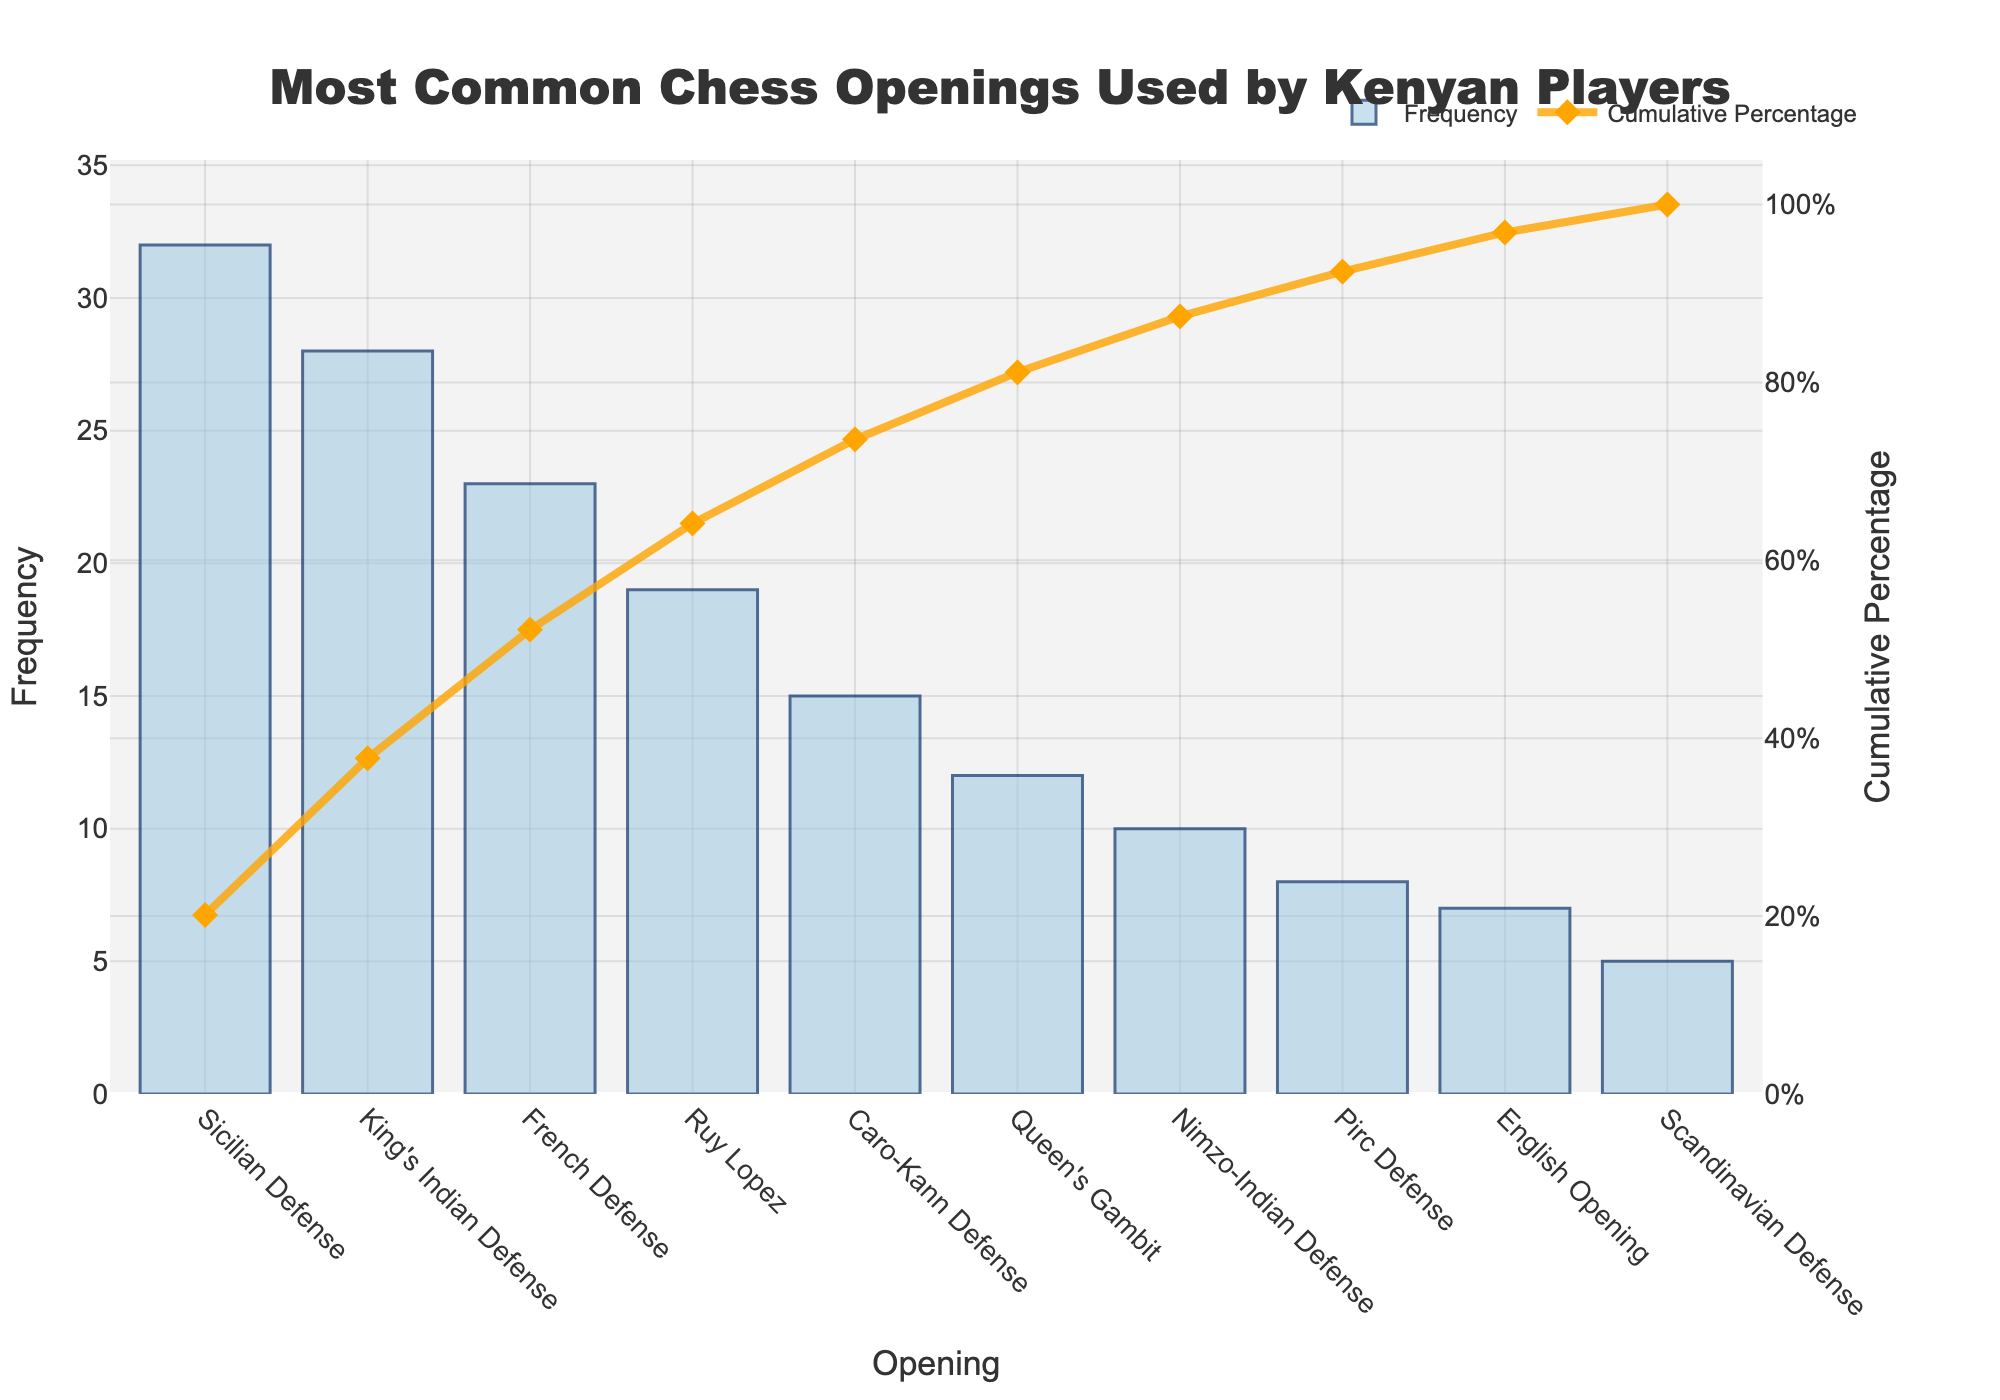How many chess openings are displayed in the figure? Count the number of bars presented on the x-axis of the Pareto chart. Each bar represents one chess opening.
Answer: 10 What is the most common chess opening used by Kenyan players? Identify the bar with the highest frequency on the y-axis. The chart shows this as the Sicilian Defense.
Answer: Sicilian Defense What color represents the frequency bars in the chart? Look at the color of the bars in the chart, which are a shade of blue.
Answer: Blue What is the cumulative percentage for the King's Indian Defense? Find the point where the cumulative percentage line intersects the King's Indian Defense bar.
Answer: 32.5% Which opening has the lowest frequency, and what is its value? Identify the shortest bar in the chart, which represents the opening with the lowest frequency and read its frequency value on the y-axis.
Answer: Scandinavian Defense, 5 What percentage of the total frequency do the top three openings contribute? Add the frequencies of the top three openings (Sicilian Defense, King's Indian Defense, French Defense), divide by the total frequency sum, and then multiply by 100. (32 + 28 + 23) / 159 * 100 = 52.83%
Answer: 52.83% How much more frequent is the Sicilian Defense compared to the Scandinavian Defense? Subtract the frequency value of the Scandinavian Defense from that of the Sicilian Defense. 32 - 5 = 27
Answer: 27 Which opening's cumulative percentage reaches just over 50%? Look at the cumulative percentage line and see where it crosses just over 50% on the y-axis. The corresponding x-axis label is the French Defense.
Answer: French Defense Is there any opening that contributes exactly 10% to the total frequency sum? Check if any bar’s height directly indicates 10% of the total frequency sum (159). Calculate 10% of 159, which is 15.9. No opening has this exact frequency.
Answer: No What is the cumulative percentage for the top five openings? Add the top five frequencies (32, 28, 23, 19, 15) to get 117. Then calculate its percentage over the total frequency sum: 117/159 * 100 = 73.58%
Answer: 73.58% 